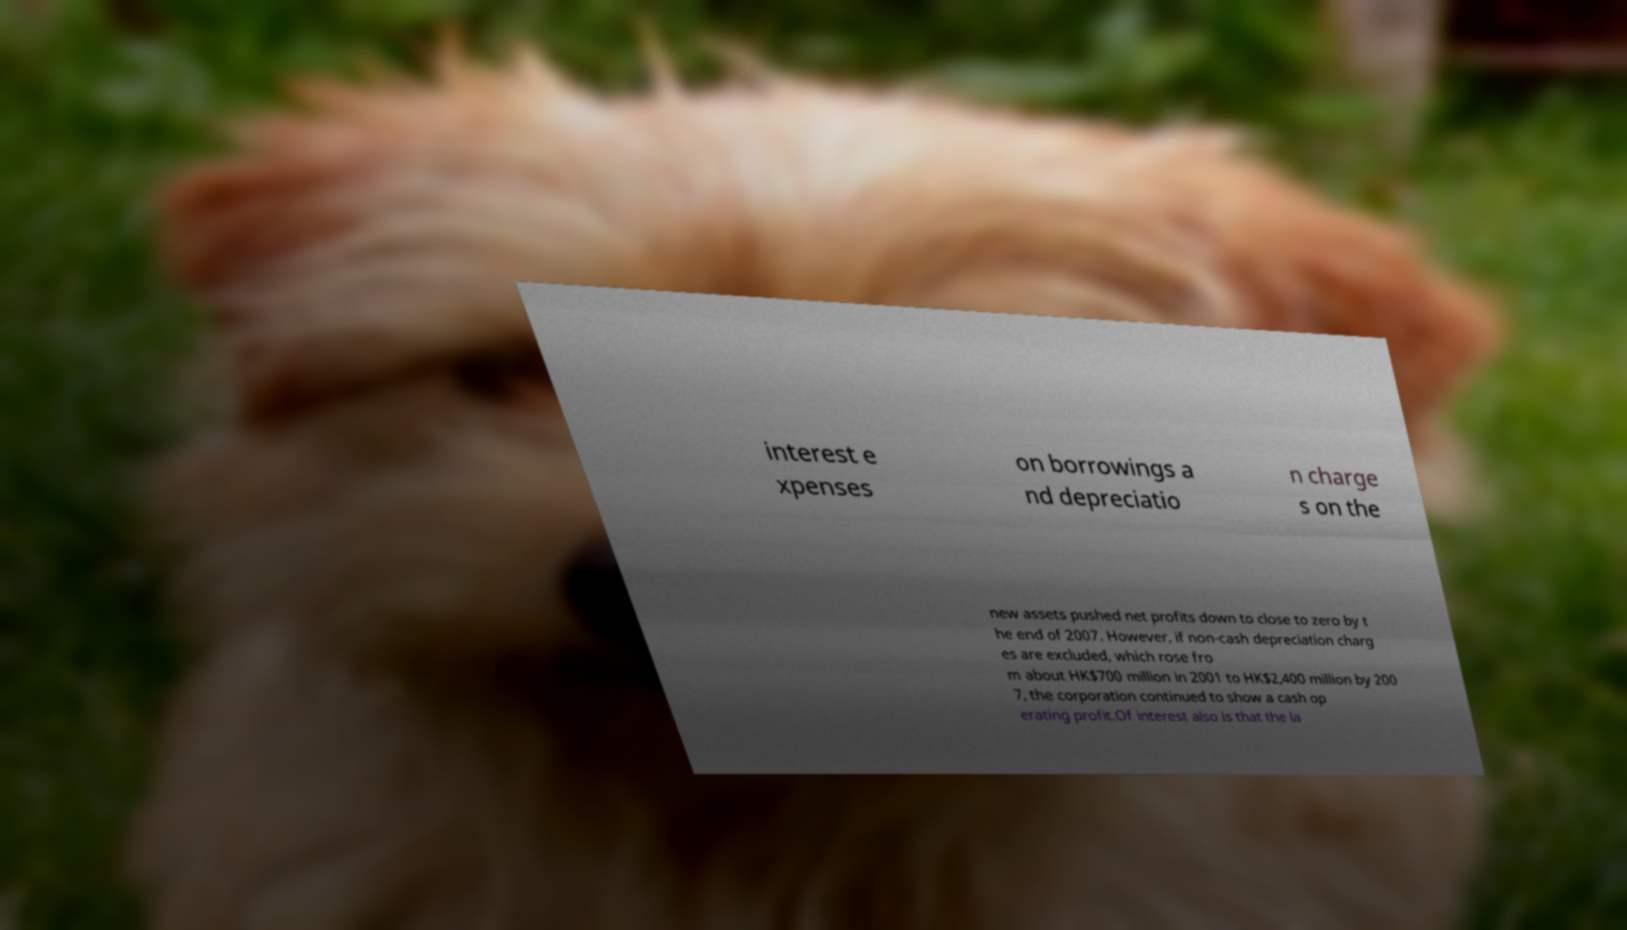Please read and relay the text visible in this image. What does it say? interest e xpenses on borrowings a nd depreciatio n charge s on the new assets pushed net profits down to close to zero by t he end of 2007. However, if non-cash depreciation charg es are excluded, which rose fro m about HK$700 million in 2001 to HK$2,400 million by 200 7, the corporation continued to show a cash op erating profit.Of interest also is that the la 